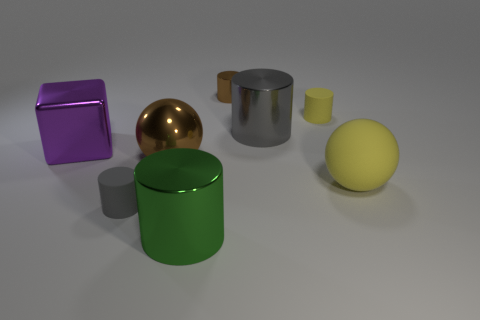How big is the metal block?
Keep it short and to the point. Large. What is the material of the large thing that is the same color as the small metallic cylinder?
Keep it short and to the point. Metal. How many rubber cylinders are the same color as the large matte object?
Make the answer very short. 1. Is the gray metal cylinder the same size as the brown ball?
Your answer should be compact. Yes. There is a metal thing to the left of the rubber cylinder that is on the left side of the large green shiny cylinder; what size is it?
Offer a very short reply. Large. Does the metal cube have the same color as the large shiny thing that is to the right of the brown metallic cylinder?
Keep it short and to the point. No. Is there a brown shiny sphere that has the same size as the brown cylinder?
Offer a very short reply. No. What is the size of the sphere that is behind the large yellow rubber object?
Ensure brevity in your answer.  Large. There is a sphere that is on the left side of the yellow rubber cylinder; are there any gray cylinders that are right of it?
Keep it short and to the point. Yes. How many other things are there of the same shape as the green object?
Give a very brief answer. 4. 